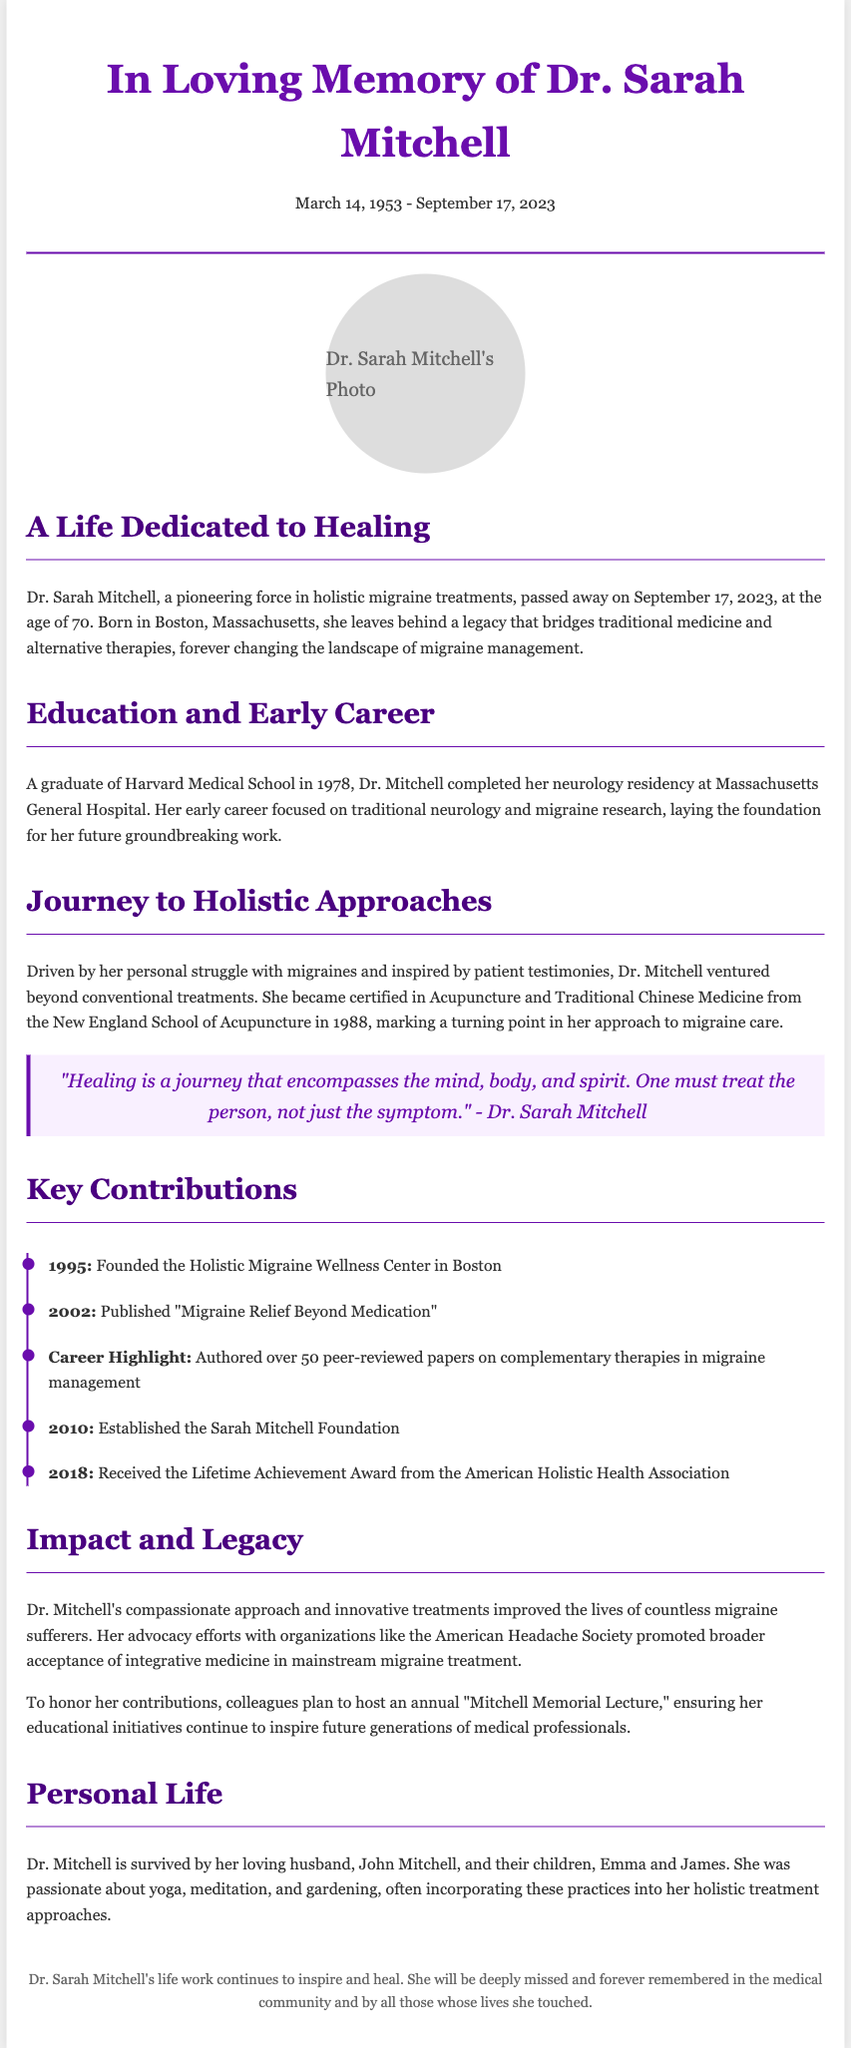What is the full name of the pioneer in holistic migraine treatments? The document introduces the individual as Dr. Sarah Mitchell, confirming her role and expertise.
Answer: Dr. Sarah Mitchell What date did Dr. Sarah Mitchell pass away? The document states the passing date of Dr. Sarah Mitchell as September 17, 2023.
Answer: September 17, 2023 What institution did Dr. Sarah Mitchell graduate from? The text mentions Dr. Mitchell graduated from Harvard Medical School, indicating her educational background.
Answer: Harvard Medical School When was the Holistic Migraine Wellness Center founded? The document lists the year of founding as 1995 in the timeline of key contributions by Dr. Mitchell.
Answer: 1995 What inspired Dr. Sarah Mitchell to explore beyond conventional treatments? The document states her personal struggle with migraines and patient testimonies as factors that motivated her change in approach.
Answer: Personal struggle with migraines Which award did Dr. Sarah Mitchell receive in 2018? The document mentions that she received the Lifetime Achievement Award from the American Holistic Health Association in 2018.
Answer: Lifetime Achievement Award What was Dr. Sarah Mitchell's significant publication in 2002? The document indicates she published "Migraine Relief Beyond Medication" in that year, marking an important contribution.
Answer: "Migraine Relief Beyond Medication" Who are the surviving family members of Dr. Sarah Mitchell? The document names her loving husband and children, providing specific details about her personal life.
Answer: John Mitchell, Emma, and James What community initiative will be established to honor Dr. Mitchell? The document mentions that colleagues plan to host an annual "Mitchell Memorial Lecture" to continue her educational impact.
Answer: "Mitchell Memorial Lecture" 